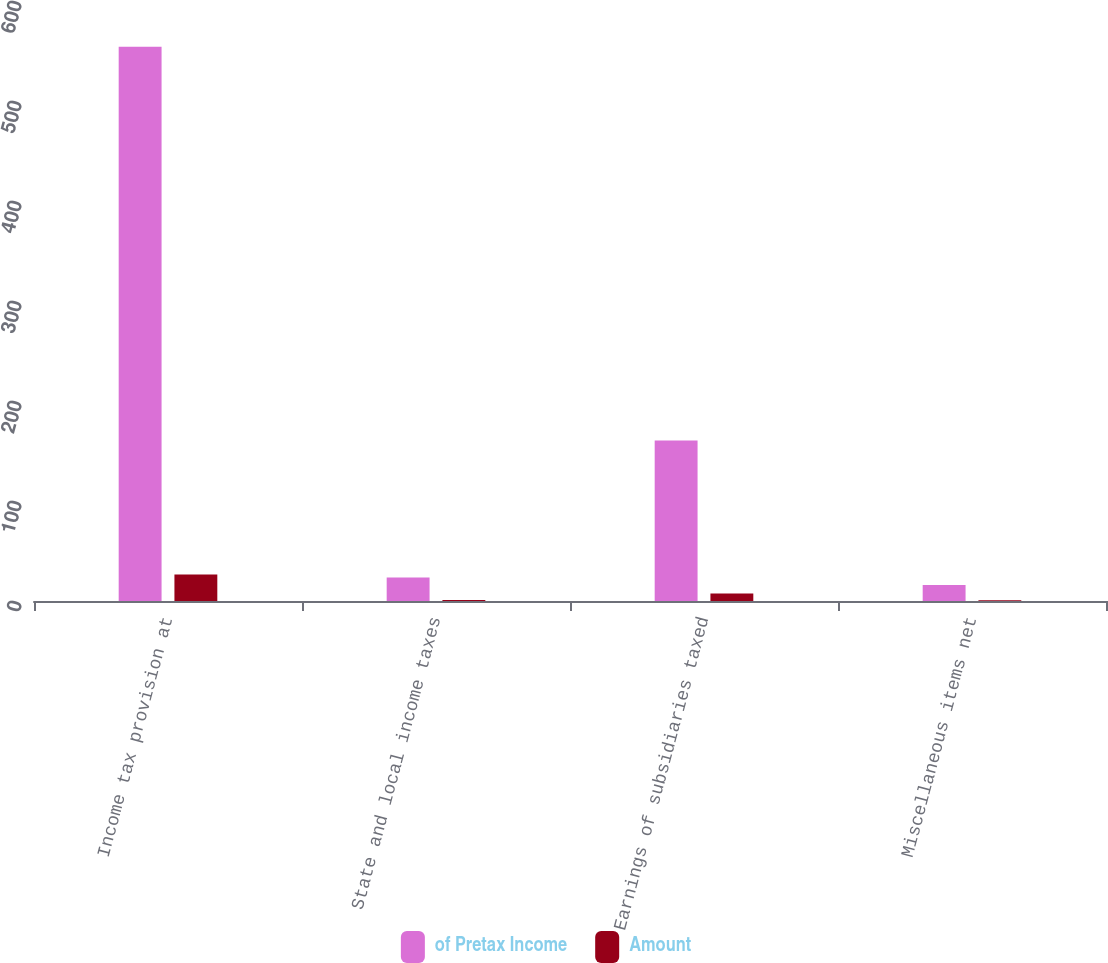<chart> <loc_0><loc_0><loc_500><loc_500><stacked_bar_chart><ecel><fcel>Income tax provision at<fcel>State and local income taxes<fcel>Earnings of subsidiaries taxed<fcel>Miscellaneous items net<nl><fcel>of Pretax Income<fcel>554.2<fcel>23.4<fcel>160.4<fcel>16<nl><fcel>Amount<fcel>26.5<fcel>1.1<fcel>7.6<fcel>0.8<nl></chart> 